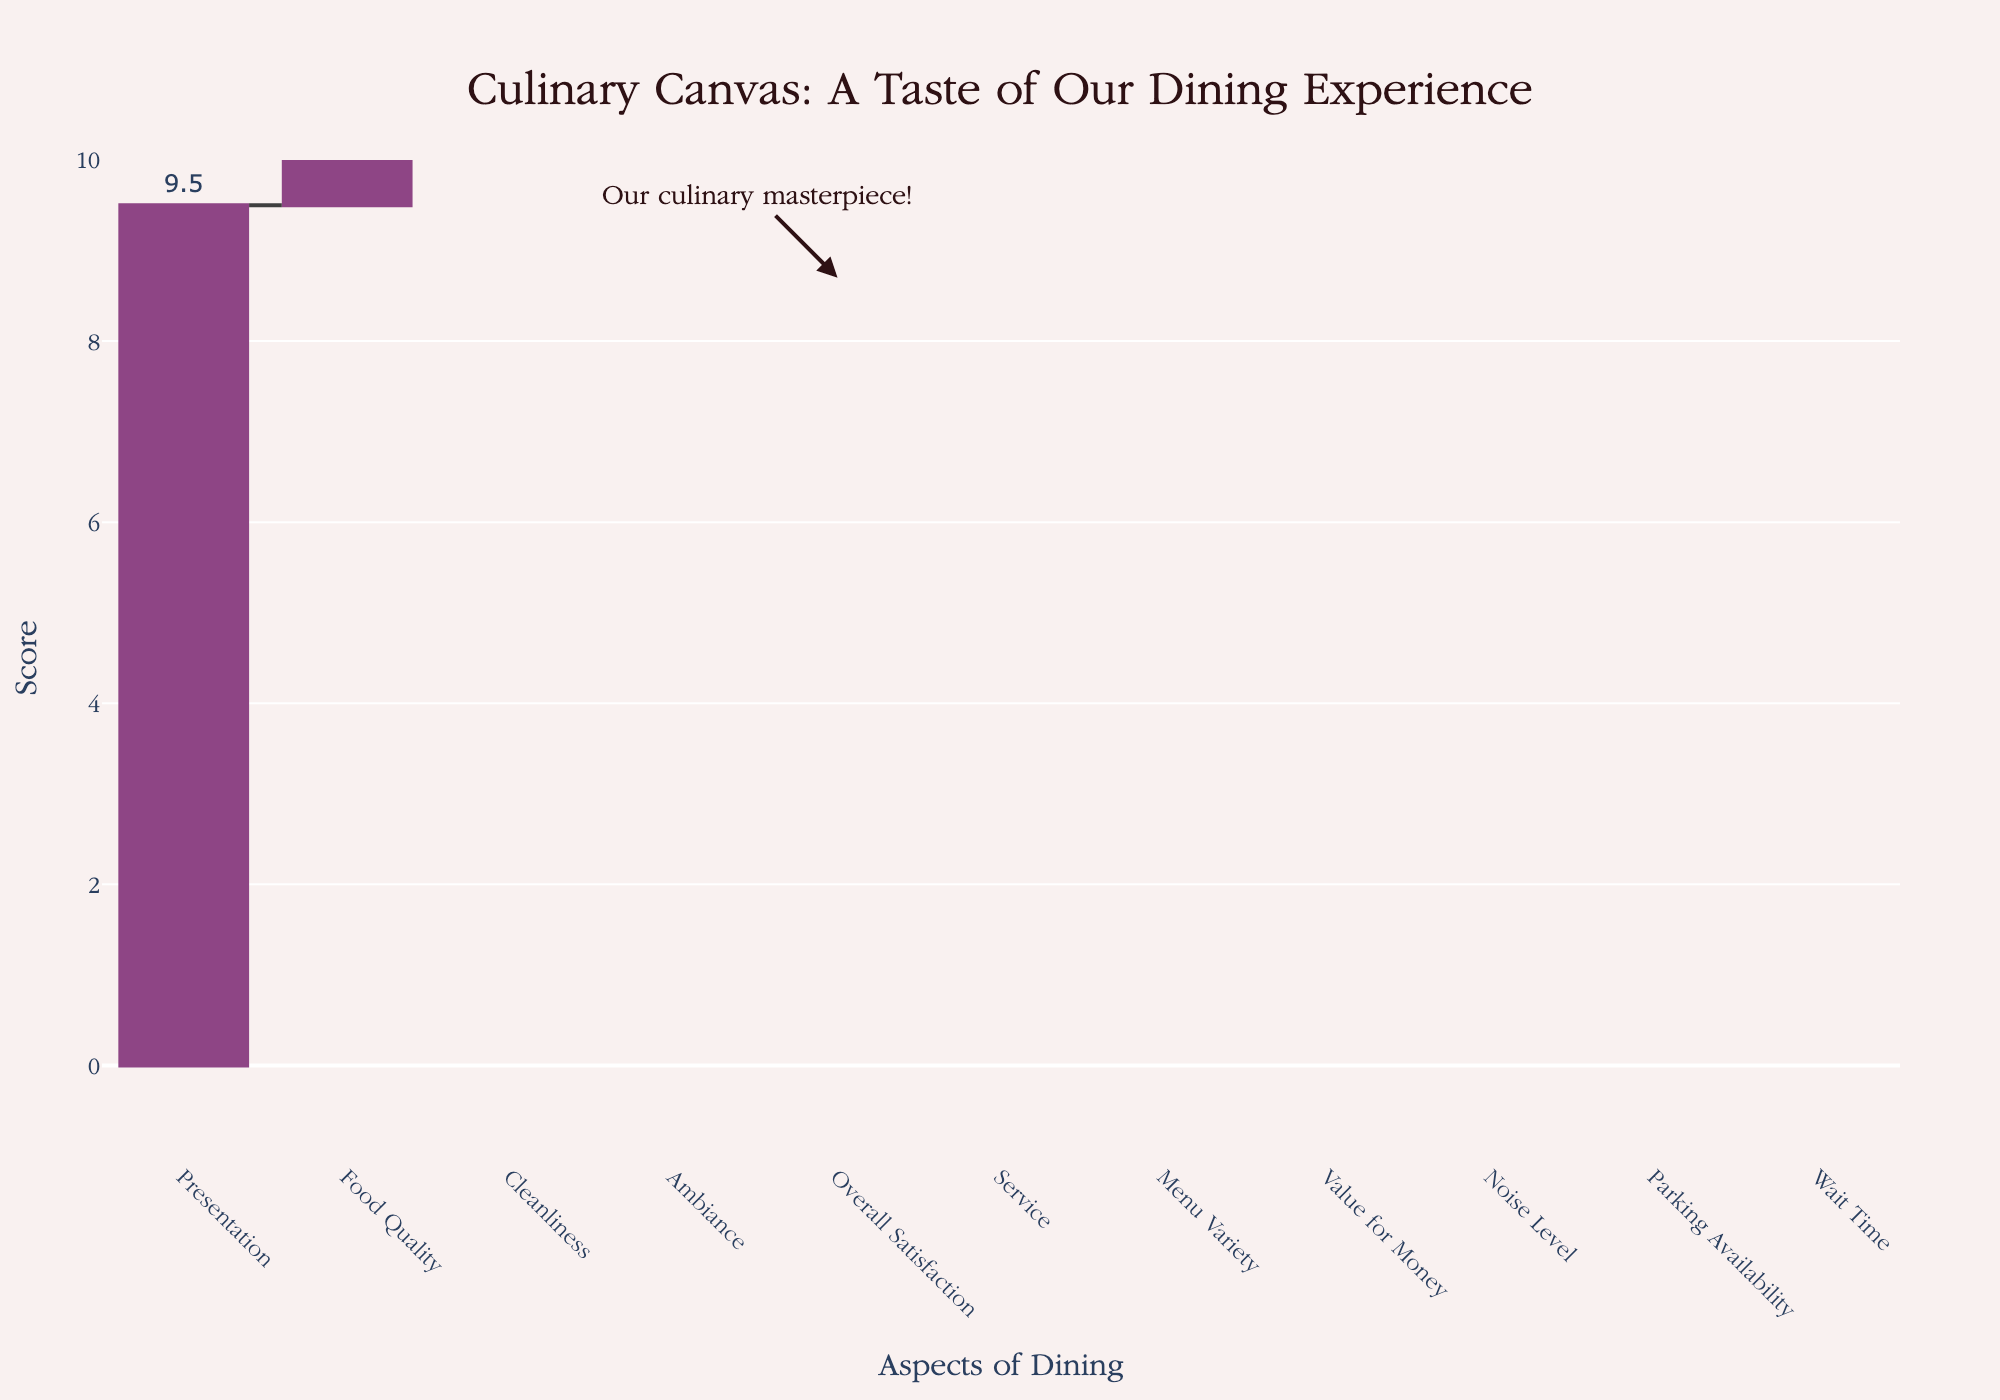What is the highest score given to any aspect of the dining experience? The chart shows the different aspects of the dining experience with their respective scores. The highest point on the y-axis corresponds to 9.5 for Presentation.
Answer: 9.5 What title is displayed on the waterfall chart? The chart title is placed at the top center and reads "Culinary Canvas: A Taste of Our Dining Experience".
Answer: Culinary Canvas: A Taste of Our Dining Experience Which aspect has the lowest score, and what is that score? By looking at the bottom of the waterfall chart, the lowest scores are for Wait Time, Noise Level, and Parking Availability, all slightly below 0. The highest among them is related to Noise Level at a score of -0.4.
Answer: Parking Availability and Wait Time, -0.5 and -0.6 Comparing Service and Cleanliness, which aspect has a higher score, and what are their scores? The chart shows the heights of the bars where Service is at 8.5 and Cleanliness is at 9.1. Therefore, Cleanliness has a higher score.
Answer: Cleanliness, 9.1 What is the overall satisfaction score? The overall satisfaction score is labeled and stands out at the midpoint of the waterfall chart with a value of 8.7.
Answer: 8.7 Which aspect contributes the most positively to the overall satisfaction, aside from the overall satisfaction itself? Apart from Overall Satisfaction, the highest individual score is for Presentation at 9.5.
Answer: Presentation What is the sum of the negative scores presented in the chart? The negative scores are for Wait Time (-0.6), Noise Level (-0.4), and Parking Availability (-0.5). Summing these values gives -1.5.
Answer: -1.5 How does the score for Value for Money compare to Menu Variety? The chart shows the scores for Value for Money and Menu Variety. Value for Money is 7.8, whereas Menu Variety is 8.3. Hence, Menu Variety is higher by 0.5.
Answer: Menu Variety, 0.5 points higher Calculate the range of the scores given in the chart. The range is calculated by taking the highest score (9.5 for Presentation) and subtracting the lowest score (-0.6 for Wait Time). This gives 9.5 - (-0.6) = 10.1.
Answer: 10.1 How many aspects have a score of 9 or higher? By looking at the chart, the scores of 9 or higher are for Food Quality, Ambiance, Presentation, and Cleanliness. This totals to 4 aspects.
Answer: 4 